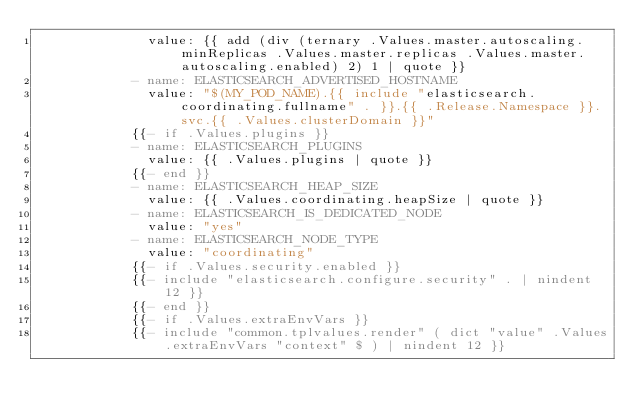Convert code to text. <code><loc_0><loc_0><loc_500><loc_500><_YAML_>              value: {{ add (div (ternary .Values.master.autoscaling.minReplicas .Values.master.replicas .Values.master.autoscaling.enabled) 2) 1 | quote }}
            - name: ELASTICSEARCH_ADVERTISED_HOSTNAME
              value: "$(MY_POD_NAME).{{ include "elasticsearch.coordinating.fullname" . }}.{{ .Release.Namespace }}.svc.{{ .Values.clusterDomain }}"
            {{- if .Values.plugins }}
            - name: ELASTICSEARCH_PLUGINS
              value: {{ .Values.plugins | quote }}
            {{- end }}
            - name: ELASTICSEARCH_HEAP_SIZE
              value: {{ .Values.coordinating.heapSize | quote }}
            - name: ELASTICSEARCH_IS_DEDICATED_NODE
              value: "yes"
            - name: ELASTICSEARCH_NODE_TYPE
              value: "coordinating"
            {{- if .Values.security.enabled }}
            {{- include "elasticsearch.configure.security" . | nindent 12 }}
            {{- end }}
            {{- if .Values.extraEnvVars }}
            {{- include "common.tplvalues.render" ( dict "value" .Values.extraEnvVars "context" $ ) | nindent 12 }}</code> 